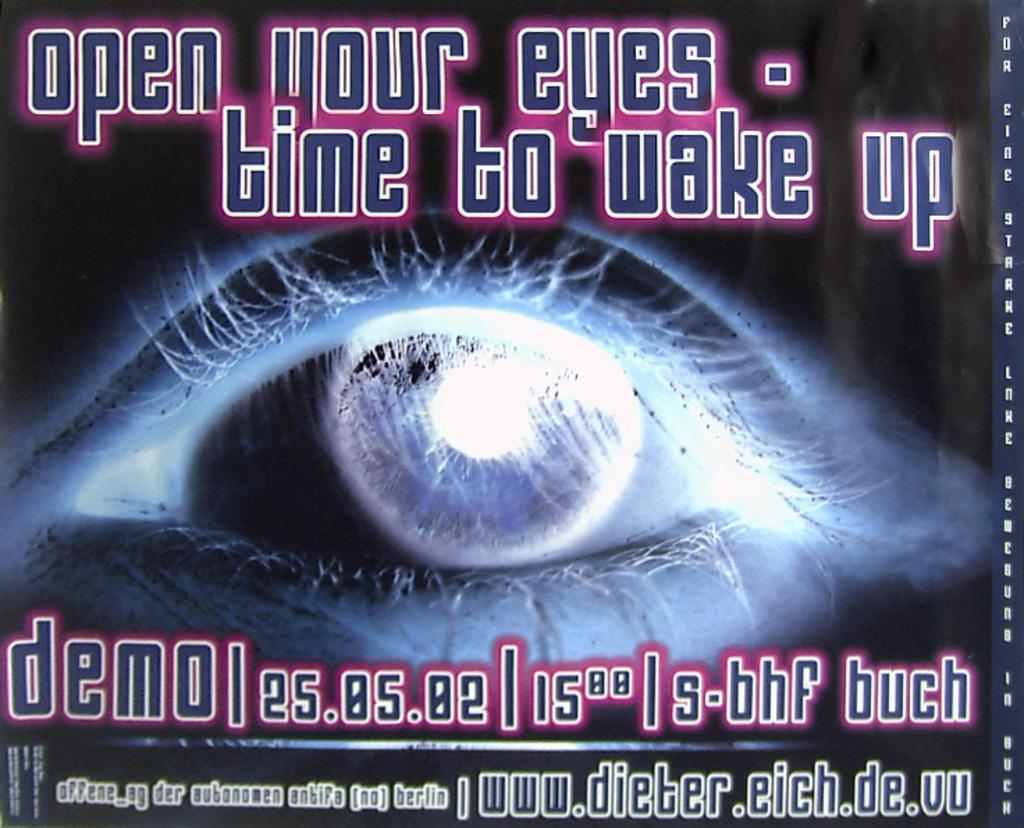<image>
Create a compact narrative representing the image presented. a poster of an eye saying open your eyes time to wake up 